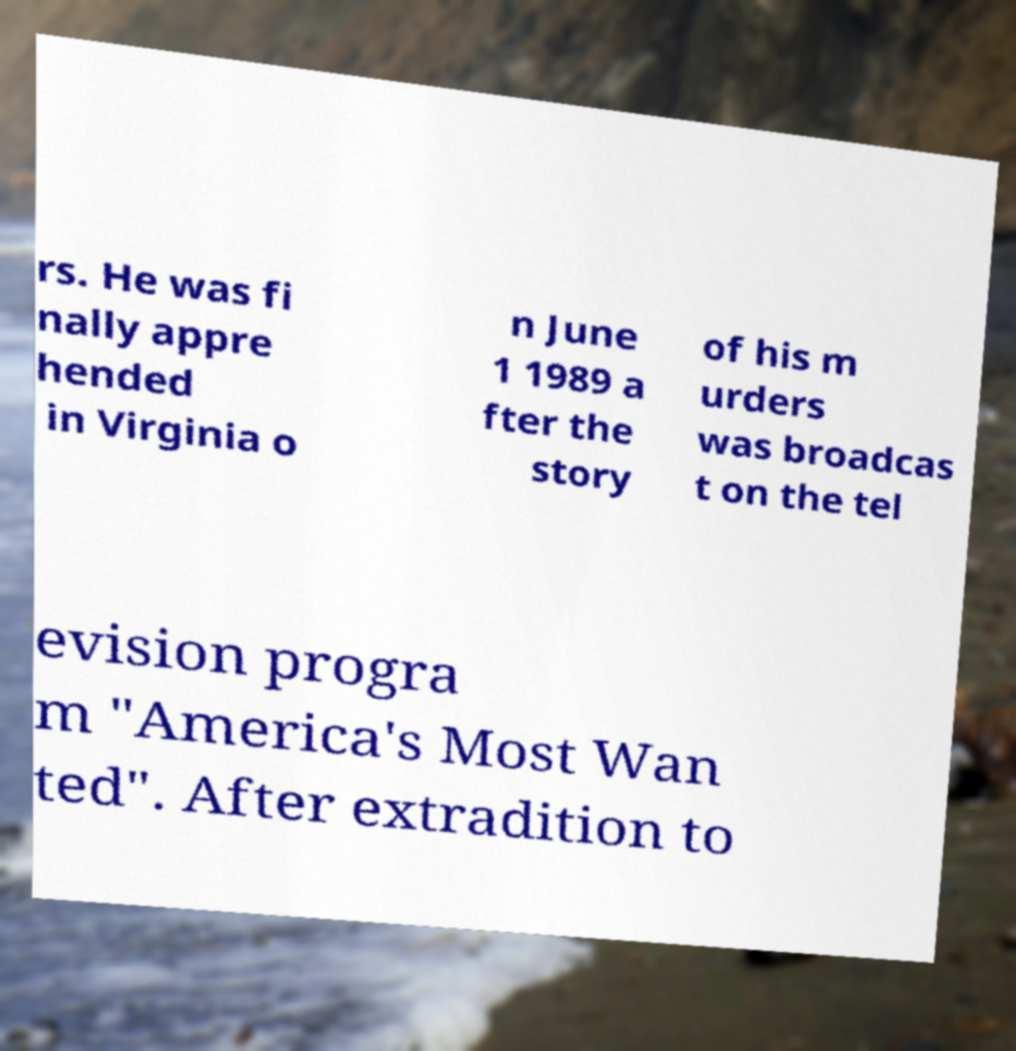Can you accurately transcribe the text from the provided image for me? rs. He was fi nally appre hended in Virginia o n June 1 1989 a fter the story of his m urders was broadcas t on the tel evision progra m "America's Most Wan ted". After extradition to 